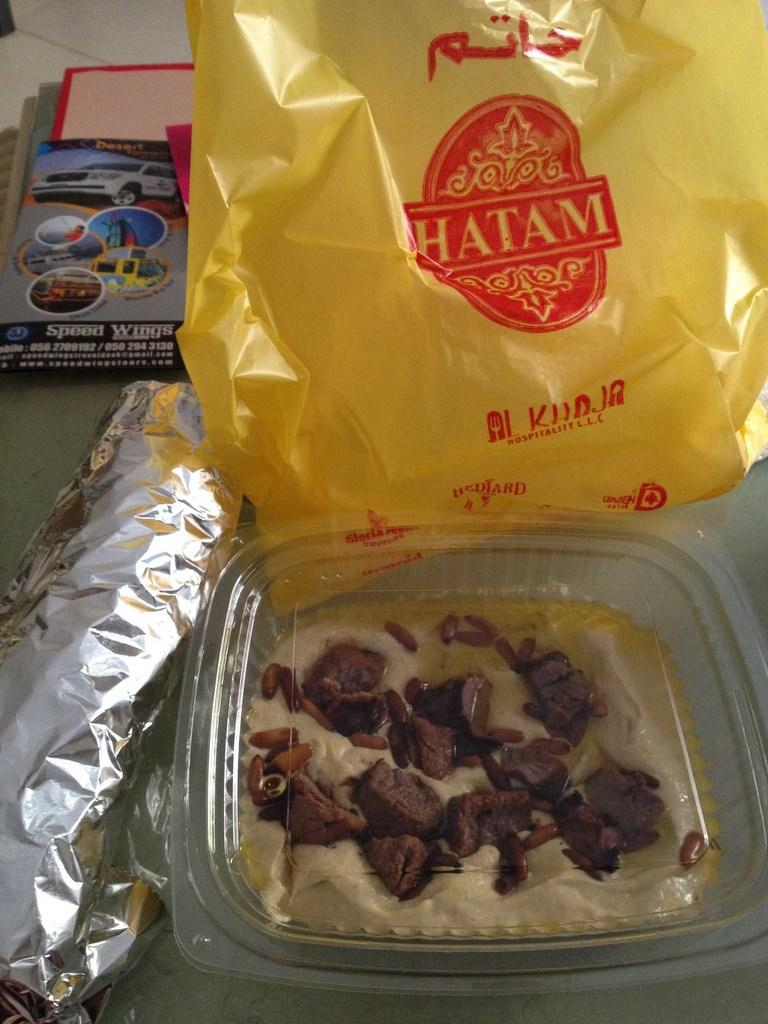What type of food can be seen in the image? The food in the image is in brown and cream colors. How is the food contained in the image? The food is in a plastic bowl. What color is the cover visible in the background of the image? The cover in the background of the image is yellow. What else can be seen on a surface in the background of the image? Papers are present on some surface in the background of the image. What type of music is being played in the image? There is no indication of music being played in the image. How many men are present in the image? There is no mention of men in the image; it only features food, a plastic bowl, and objects in the background. 